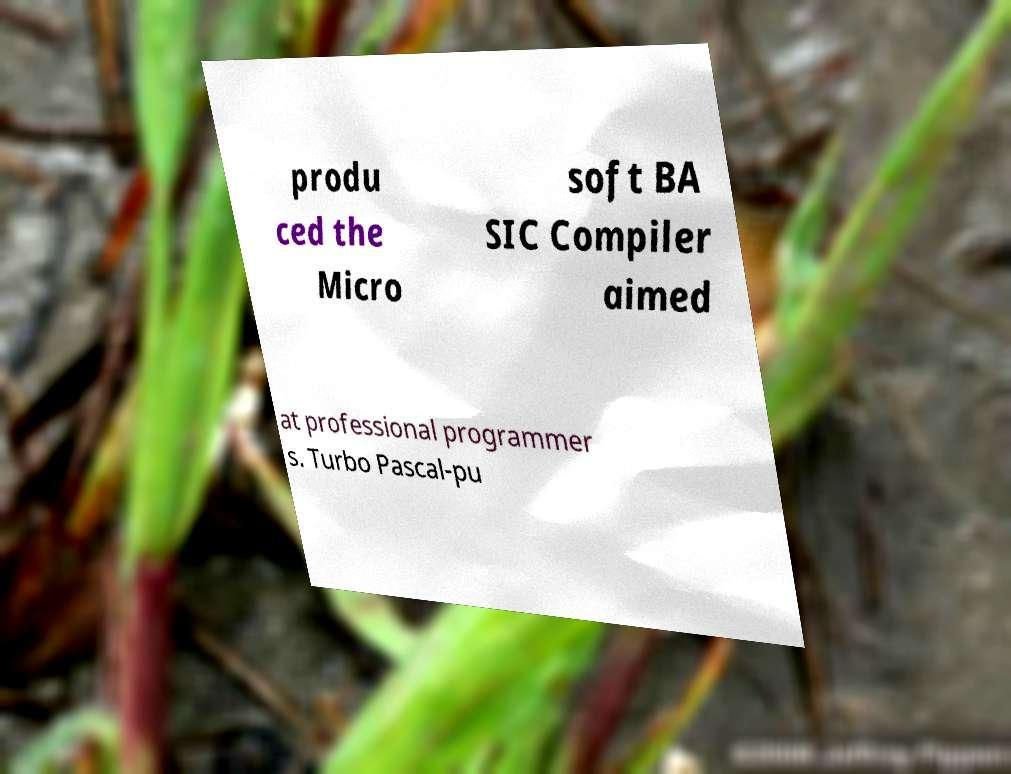For documentation purposes, I need the text within this image transcribed. Could you provide that? produ ced the Micro soft BA SIC Compiler aimed at professional programmer s. Turbo Pascal-pu 